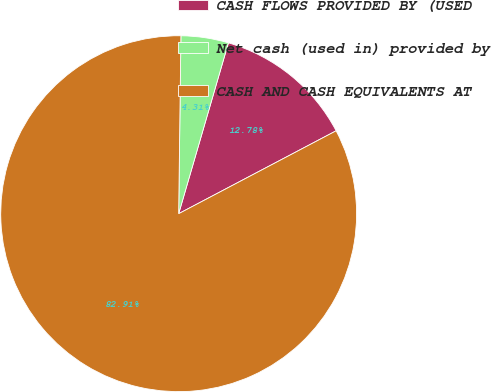Convert chart to OTSL. <chart><loc_0><loc_0><loc_500><loc_500><pie_chart><fcel>CASH FLOWS PROVIDED BY (USED<fcel>Net cash (used in) provided by<fcel>CASH AND CASH EQUIVALENTS AT<nl><fcel>12.78%<fcel>4.31%<fcel>82.92%<nl></chart> 